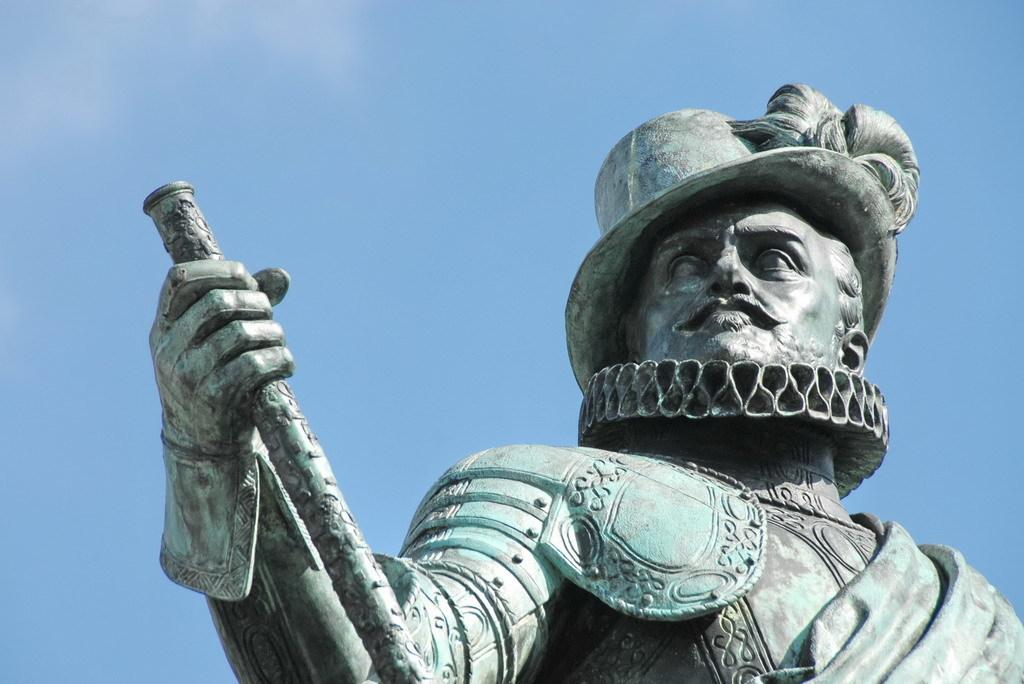What is located on the right side of the image? There is a statue of a person on the right side of the image. What is the person in the statue wearing? The person depicted in the statue is wearing a cap. What is the person in the statue holding? The person is holding a stick with one hand. What can be seen in the background of the image? There are clouds in the background of the image. What color is the sky in the image? The sky is blue in the image. How many rays of comfort can be seen emanating from the statue's fingers in the image? There are no rays of comfort or fingers visible in the image, as it features a statue of a person holding a stick. 